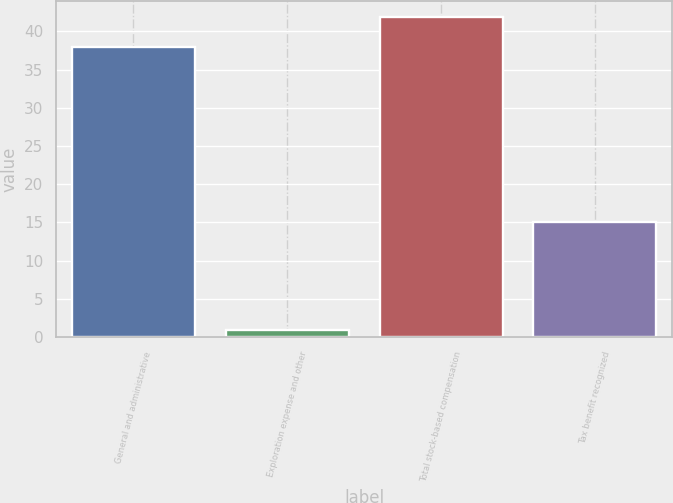Convert chart to OTSL. <chart><loc_0><loc_0><loc_500><loc_500><bar_chart><fcel>General and administrative<fcel>Exploration expense and other<fcel>Total stock-based compensation<fcel>Tax benefit recognized<nl><fcel>38<fcel>1<fcel>41.8<fcel>15<nl></chart> 